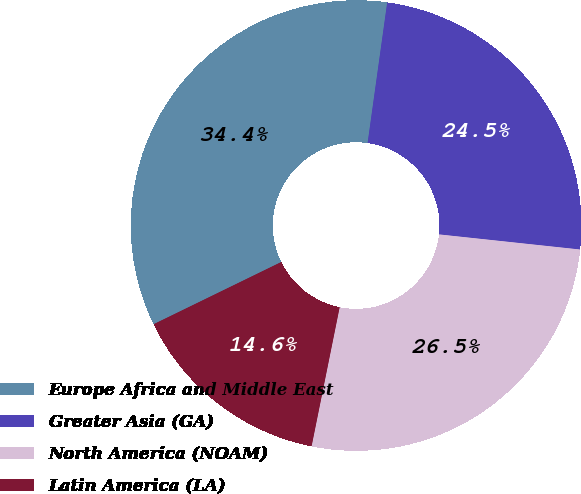Convert chart. <chart><loc_0><loc_0><loc_500><loc_500><pie_chart><fcel>Europe Africa and Middle East<fcel>Greater Asia (GA)<fcel>North America (NOAM)<fcel>Latin America (LA)<nl><fcel>34.42%<fcel>24.49%<fcel>26.47%<fcel>14.61%<nl></chart> 